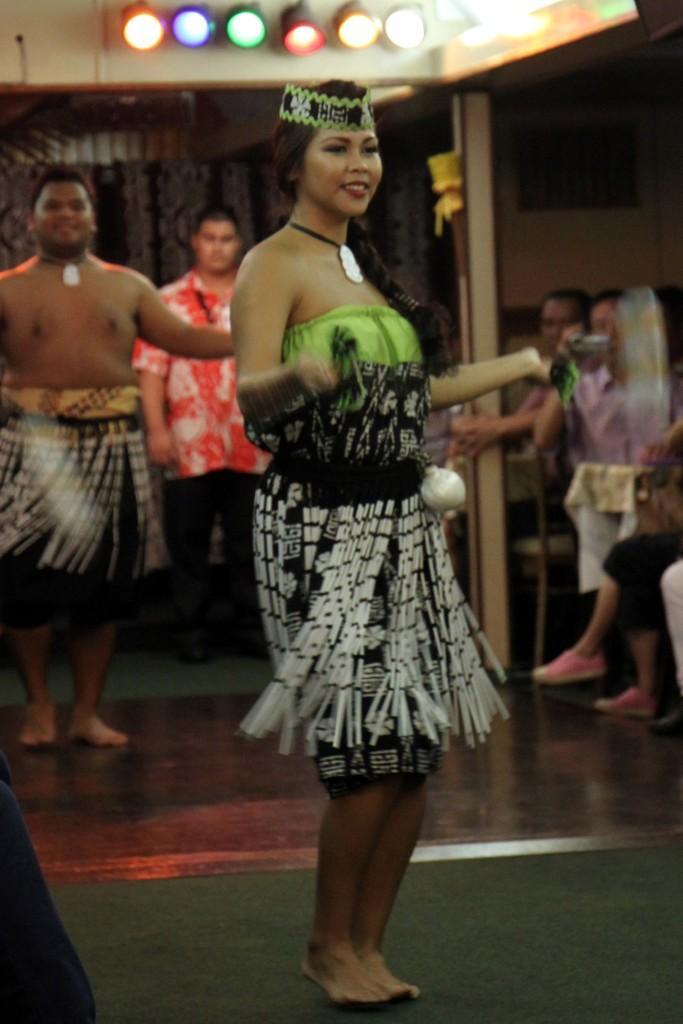Please provide a concise description of this image. In the image in the center we can see two persons were standing and they were smiling,which we can see on their faces. And they were in different costumes. In the background there is a wall,roof,pole,lights,chairs,one person standing,few people were sitting on the chair and holding some objects. 